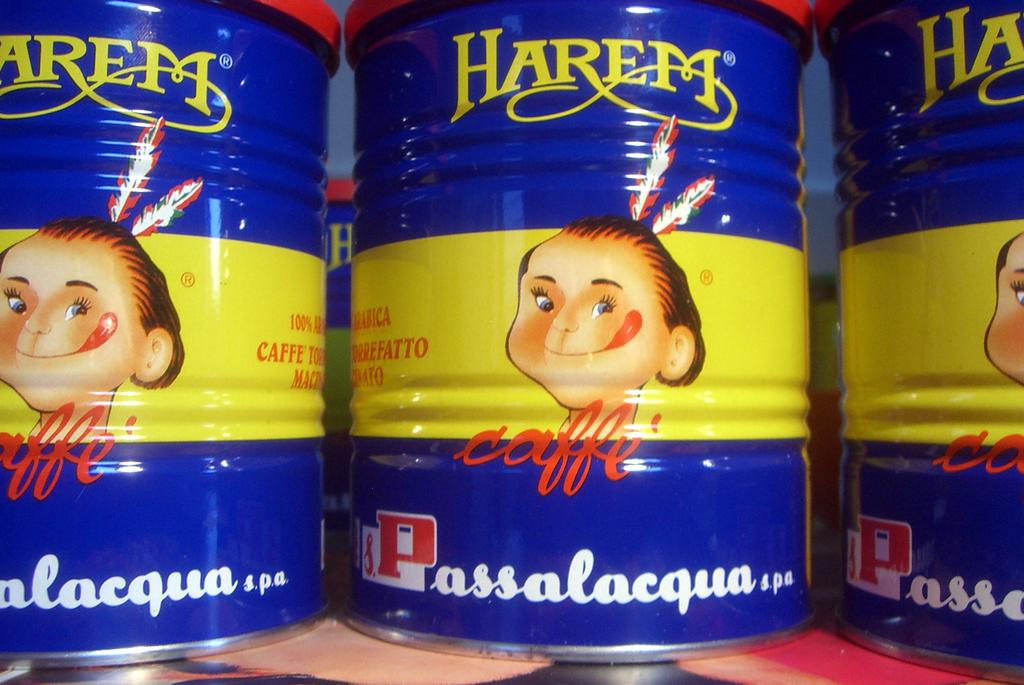<image>
Write a terse but informative summary of the picture. Several cans of Harem brand coffee are on display. 